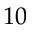<formula> <loc_0><loc_0><loc_500><loc_500>1 0</formula> 